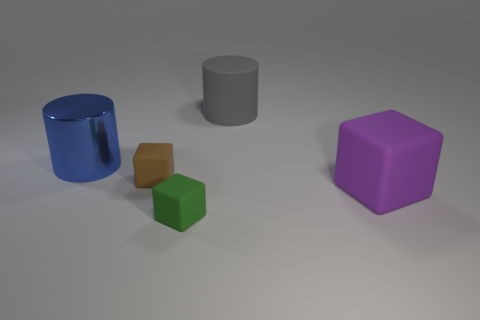Is there a small blue rubber object of the same shape as the purple object?
Provide a short and direct response. No. Do the big rubber cylinder and the rubber thing on the left side of the green object have the same color?
Ensure brevity in your answer.  No. Are there any red objects of the same size as the green rubber thing?
Make the answer very short. No. Is the material of the purple thing the same as the cylinder in front of the gray rubber cylinder?
Your response must be concise. No. Are there more gray things than brown shiny balls?
Make the answer very short. Yes. How many balls are either small green rubber objects or big rubber objects?
Your answer should be very brief. 0. The large matte block has what color?
Offer a terse response. Purple. There is a cylinder that is on the left side of the small brown thing; is it the same size as the rubber thing behind the small brown thing?
Provide a succinct answer. Yes. Are there fewer purple matte blocks than big green metallic blocks?
Your answer should be compact. No. There is a blue metal cylinder; what number of large cylinders are behind it?
Provide a succinct answer. 1. 